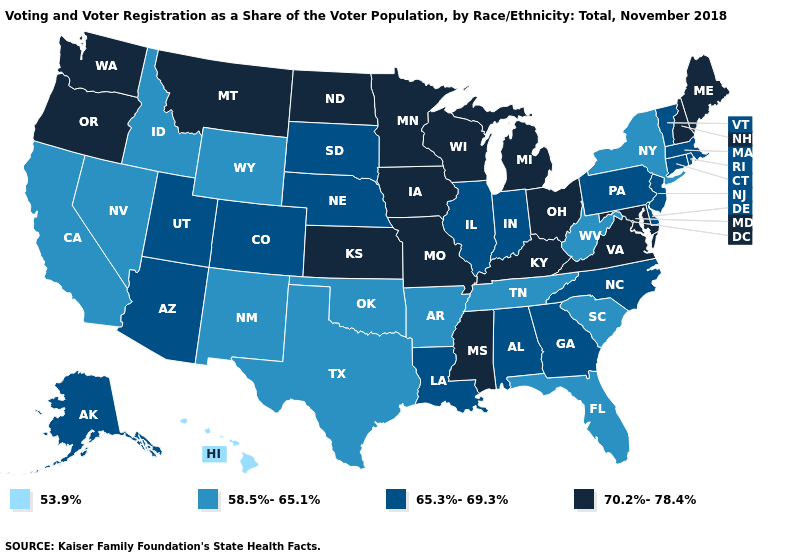Does Nebraska have the same value as Oklahoma?
Short answer required. No. What is the value of Massachusetts?
Write a very short answer. 65.3%-69.3%. Does the first symbol in the legend represent the smallest category?
Concise answer only. Yes. Among the states that border New Hampshire , which have the highest value?
Short answer required. Maine. Does Michigan have the highest value in the USA?
Write a very short answer. Yes. What is the value of Arkansas?
Answer briefly. 58.5%-65.1%. Name the states that have a value in the range 58.5%-65.1%?
Short answer required. Arkansas, California, Florida, Idaho, Nevada, New Mexico, New York, Oklahoma, South Carolina, Tennessee, Texas, West Virginia, Wyoming. What is the lowest value in the West?
Short answer required. 53.9%. Does Nevada have the lowest value in the USA?
Be succinct. No. What is the value of Vermont?
Be succinct. 65.3%-69.3%. What is the value of Massachusetts?
Answer briefly. 65.3%-69.3%. Among the states that border Idaho , does Nevada have the highest value?
Short answer required. No. Which states hav the highest value in the West?
Quick response, please. Montana, Oregon, Washington. What is the highest value in states that border Idaho?
Write a very short answer. 70.2%-78.4%. What is the highest value in the USA?
Short answer required. 70.2%-78.4%. 